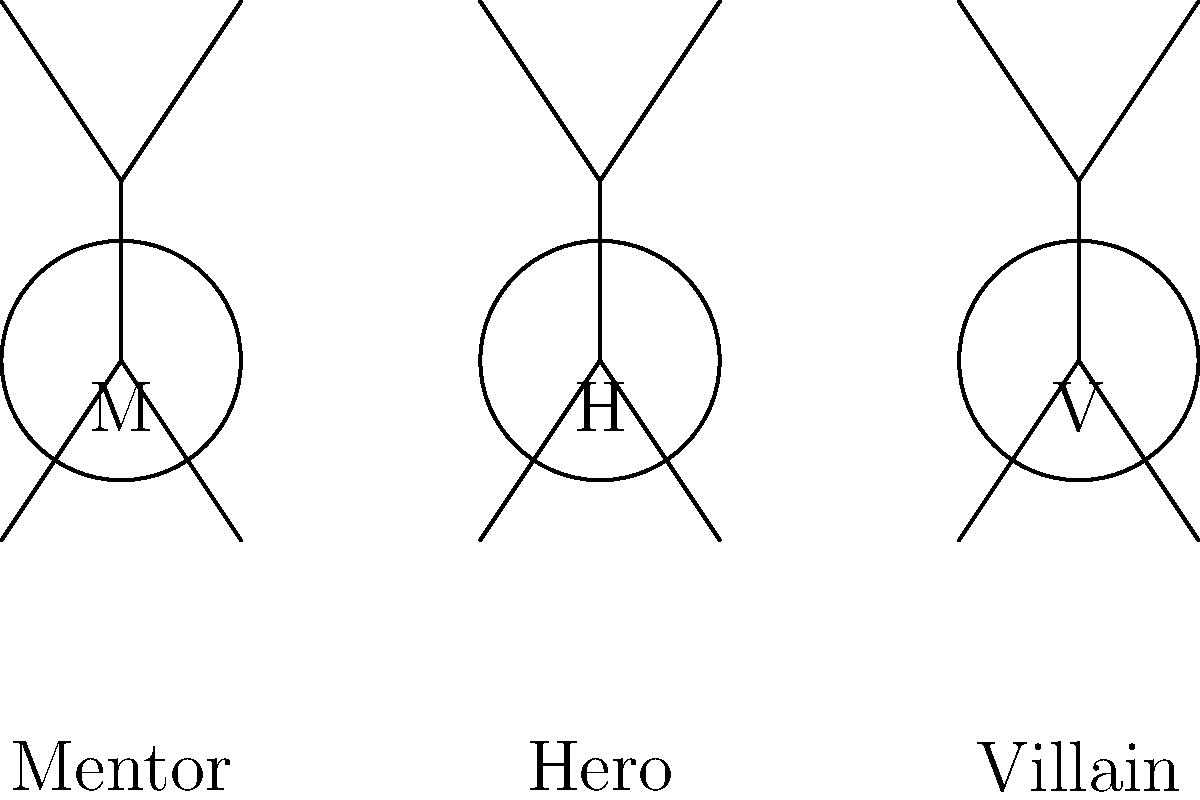In epic stories, which character archetype typically guides and supports the hero on their journey, often providing wisdom and resources? To answer this question, let's break down the common character archetypes found in epic stories:

1. Hero (H): The main protagonist who embarks on a journey or quest.
2. Mentor (M): A wise, experienced character who guides and supports the hero.
3. Villain (V): The antagonist who opposes the hero and creates conflict.

In epic storytelling:

1. The Hero is usually the central character, facing challenges and growing throughout the story.
2. The Mentor plays a crucial role in the hero's development by:
   a) Providing wisdom and advice
   b) Offering training or resources
   c) Supporting the hero during difficult times
   d) Often serving as a father/mother figure
3. The Villain creates obstacles and conflicts for the hero to overcome.

Examples of mentors in popular stories include:
- Gandalf in "The Lord of the Rings" (although not part of your experience)
- Dumbledore in "Harry Potter"
- Obi-Wan Kenobi in "Star Wars"

These characters consistently guide and support the hero, sharing their knowledge and experience to help the protagonist succeed in their quest.
Answer: Mentor 